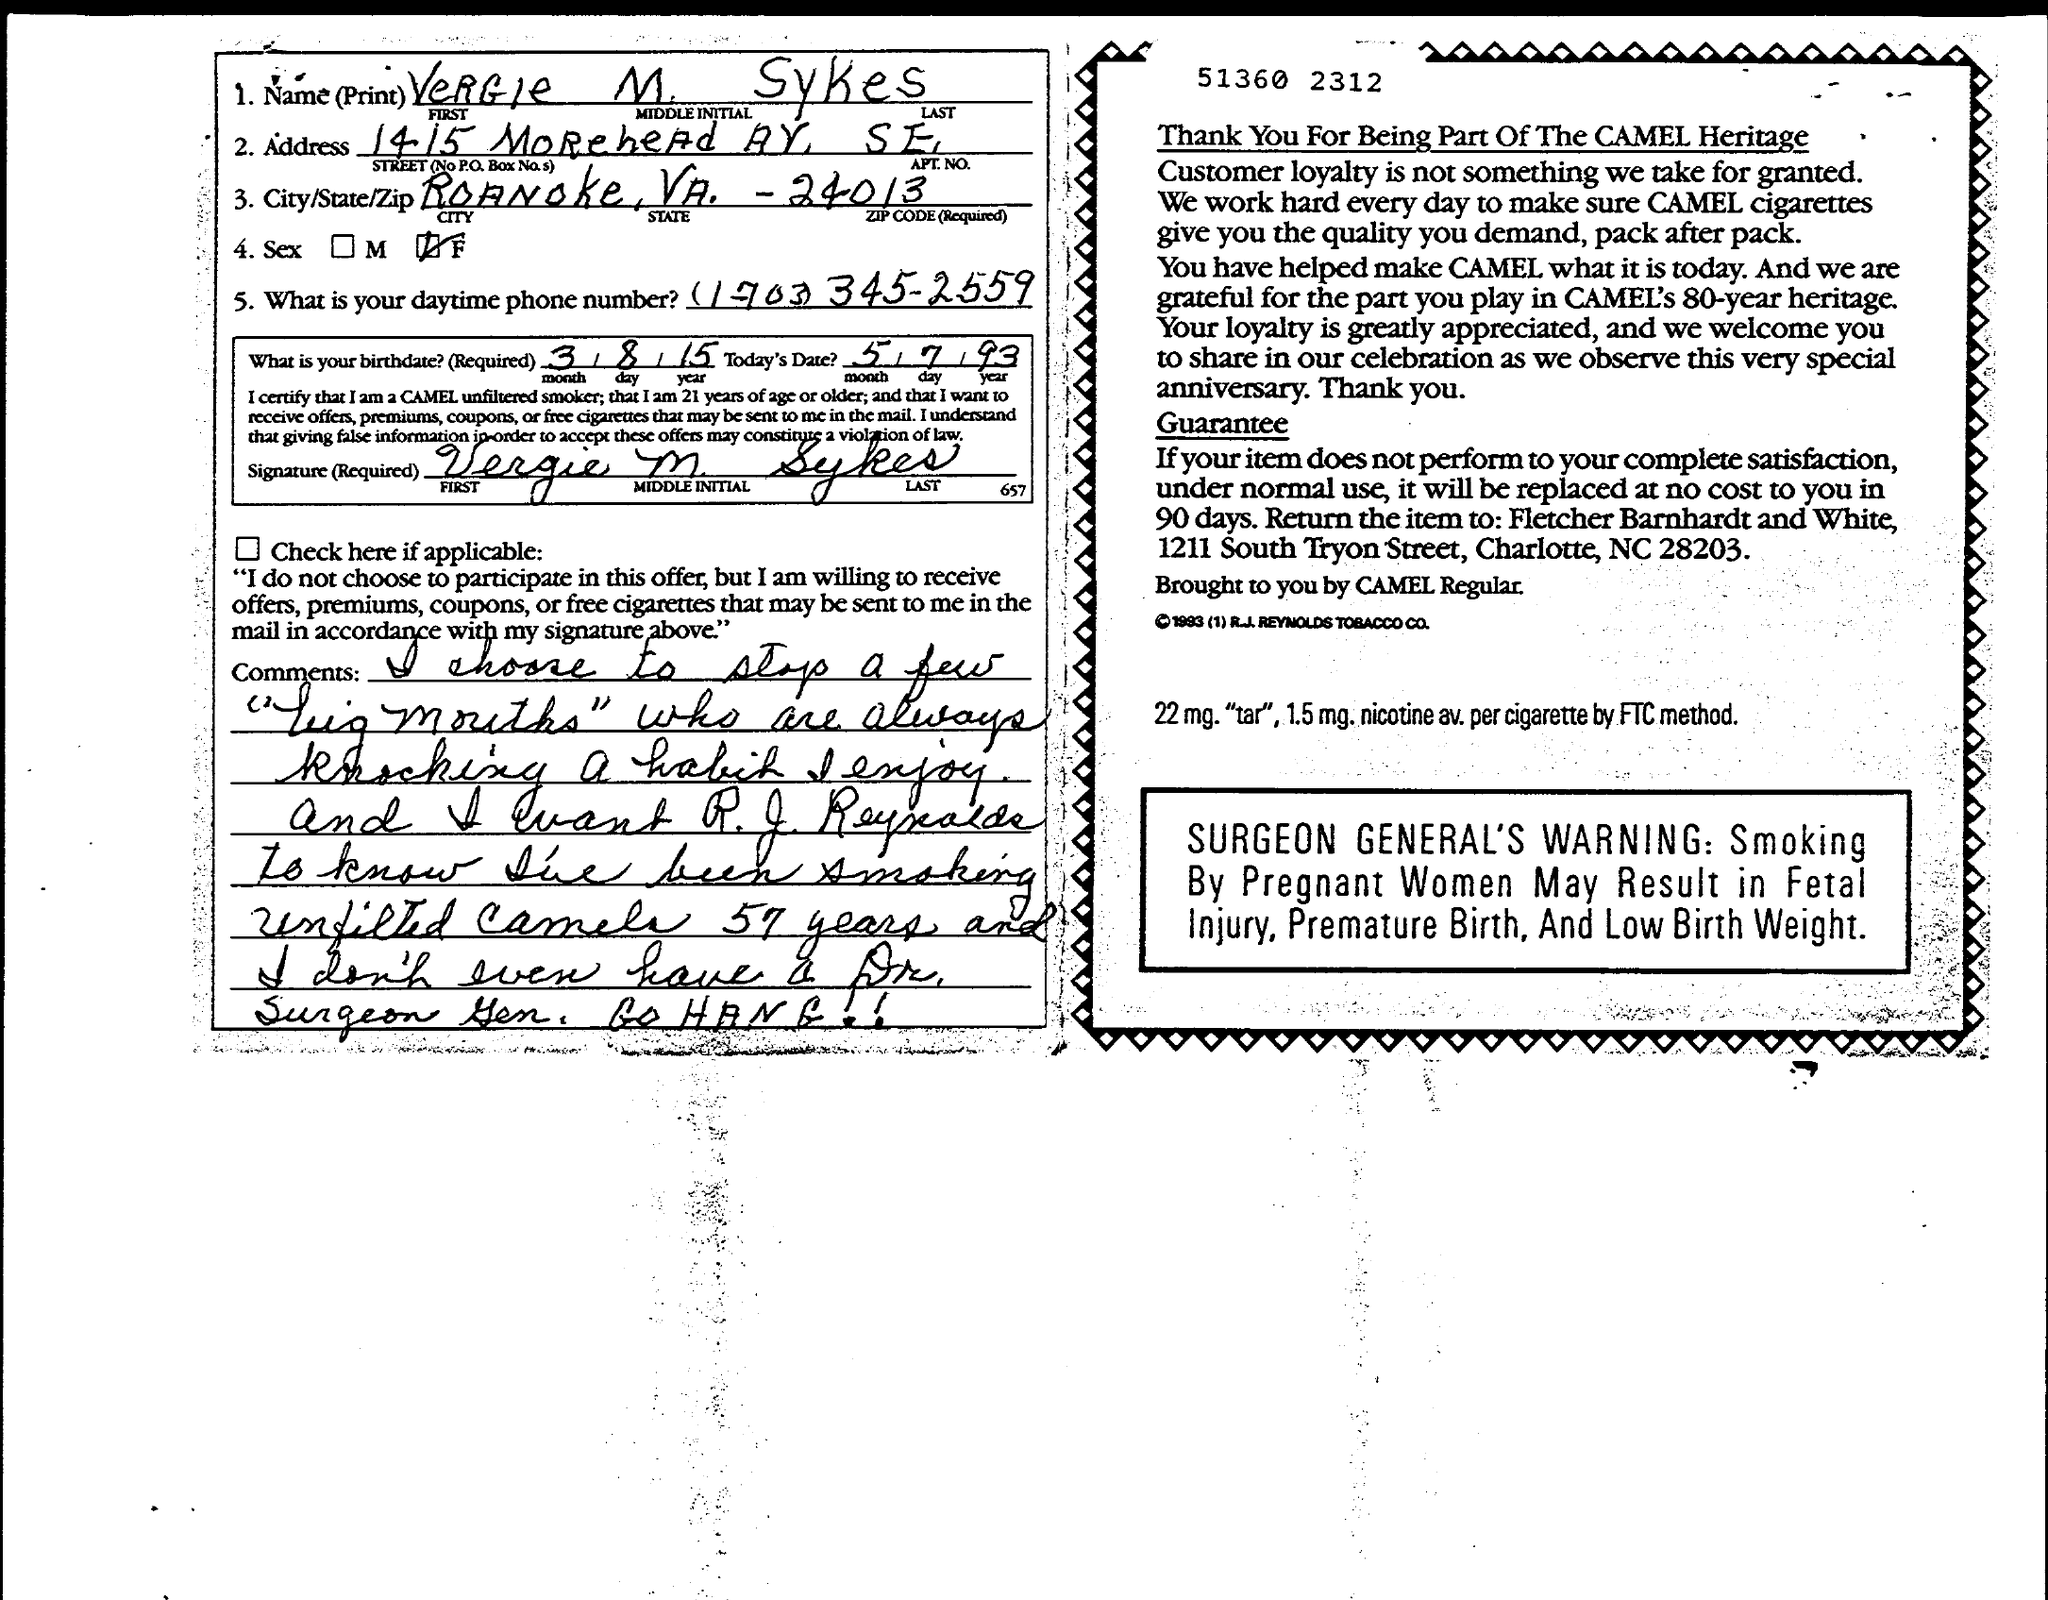What is the name mentioned ?
Offer a terse response. VeRGIe  M. SYKes. What is the city/state /zip mentioned?
Offer a very short reply. Roanoke, VA, -24013. 